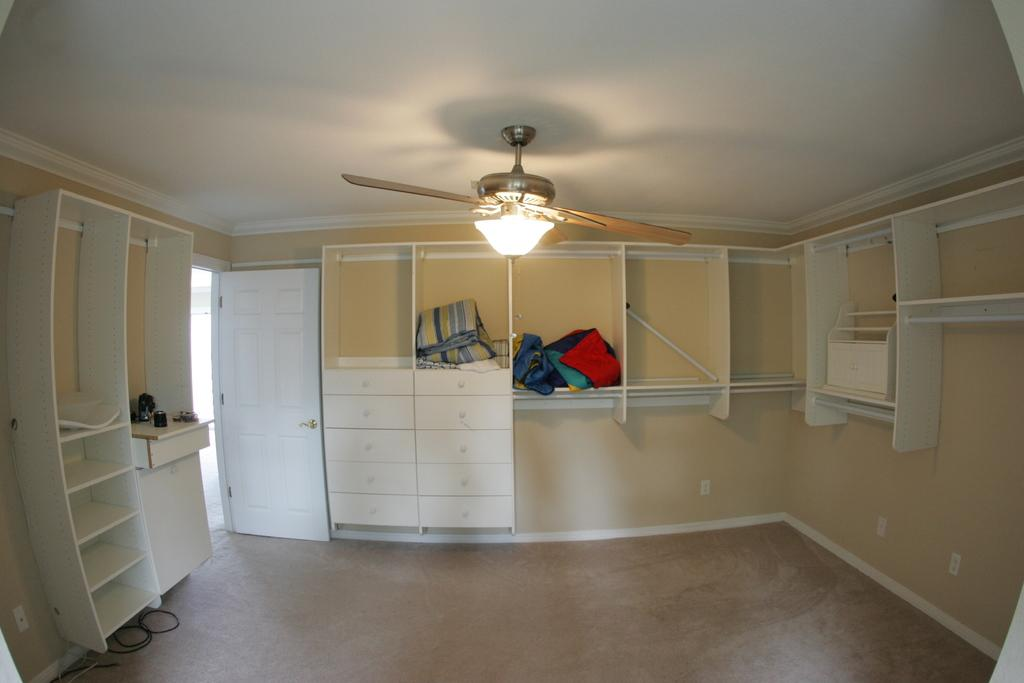What type of furniture is present in the image? There are cupboards in the image. What color are the cupboards? The cupboards are white. What is stored inside the cupboards? There are clothes in the cupboards. What is the color of the clothes? The clothes are multi-colored. What appliance can be seen attached to the roof in the image? There is a fan attached to the roof in the image. What color is the wall in the image? The wall is in cream color. How many pies are displayed on the cupboards in the image? There are no pies present in the image; the cupboards contain multi-colored clothes. 